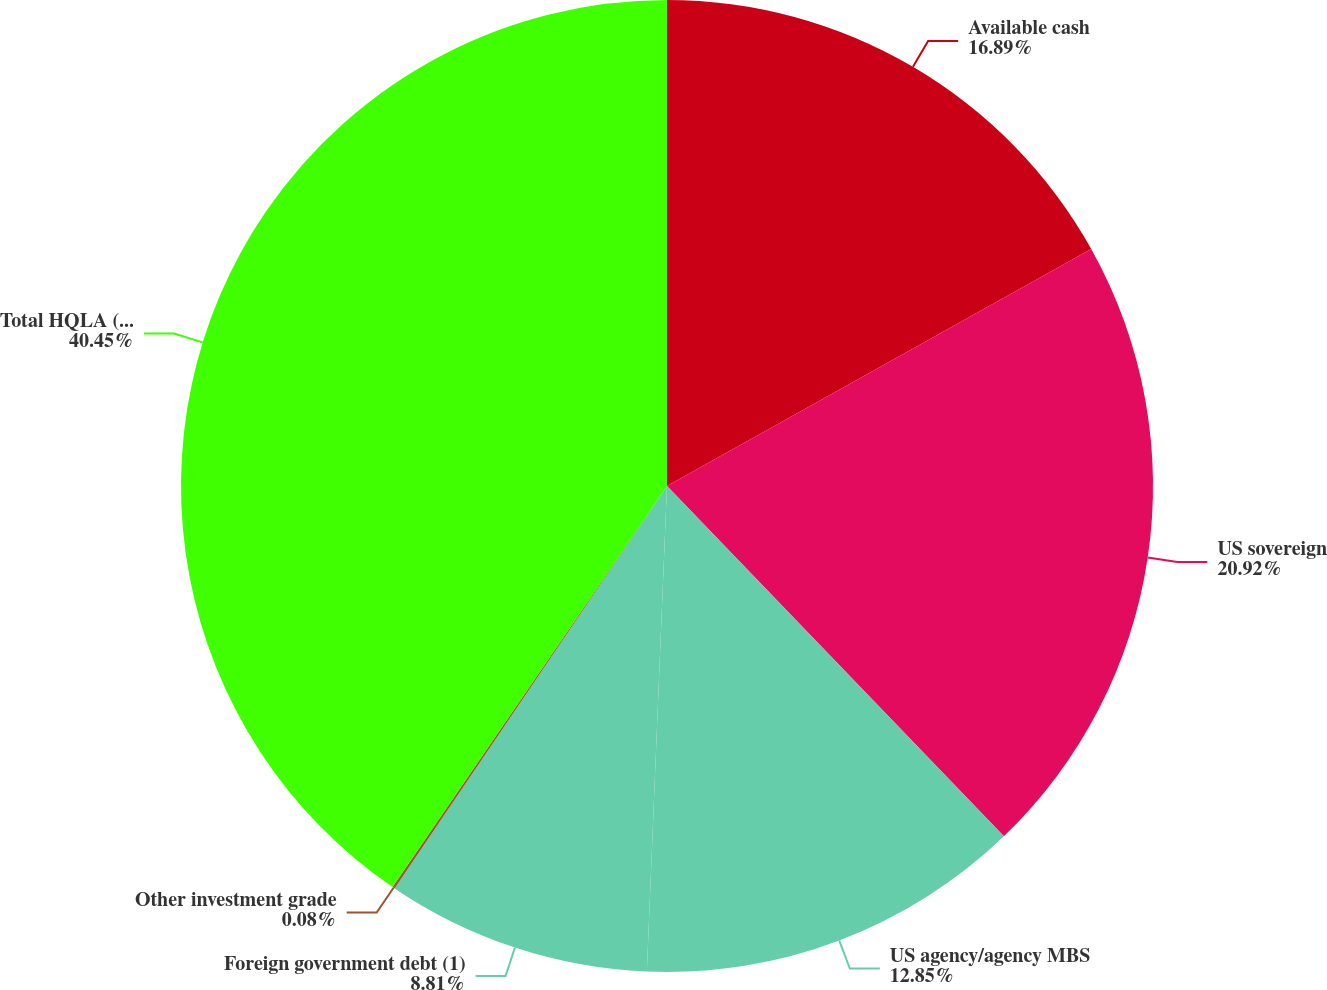<chart> <loc_0><loc_0><loc_500><loc_500><pie_chart><fcel>Available cash<fcel>US sovereign<fcel>US agency/agency MBS<fcel>Foreign government debt (1)<fcel>Other investment grade<fcel>Total HQLA (AVG)<nl><fcel>16.89%<fcel>20.92%<fcel>12.85%<fcel>8.81%<fcel>0.08%<fcel>40.45%<nl></chart> 